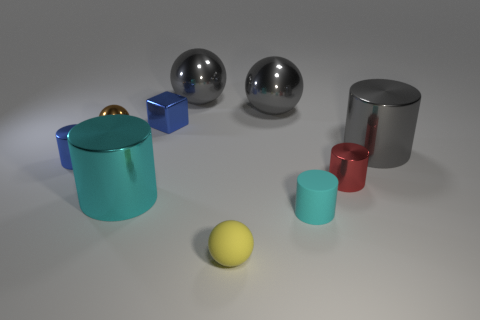Subtract all green spheres. Subtract all green cubes. How many spheres are left? 4 Subtract all cyan cubes. How many gray cylinders are left? 1 Add 1 big things. How many tiny cyans exist? 0 Subtract all brown cubes. Subtract all small brown shiny objects. How many objects are left? 9 Add 8 tiny cyan objects. How many tiny cyan objects are left? 9 Add 3 tiny blocks. How many tiny blocks exist? 4 Subtract all gray spheres. How many spheres are left? 2 Subtract all red cylinders. How many cylinders are left? 4 Subtract 1 yellow spheres. How many objects are left? 9 Subtract all gray balls. How many were subtracted if there are1gray balls left? 1 